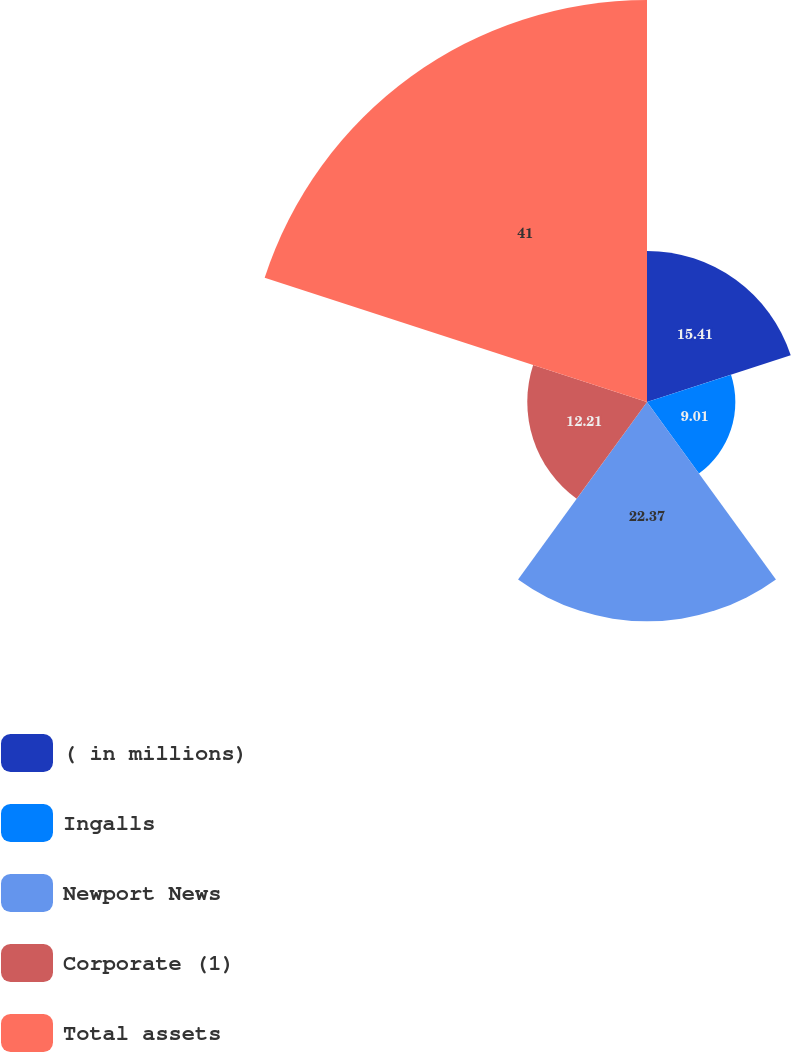Convert chart. <chart><loc_0><loc_0><loc_500><loc_500><pie_chart><fcel>( in millions)<fcel>Ingalls<fcel>Newport News<fcel>Corporate (1)<fcel>Total assets<nl><fcel>15.41%<fcel>9.01%<fcel>22.37%<fcel>12.21%<fcel>41.0%<nl></chart> 